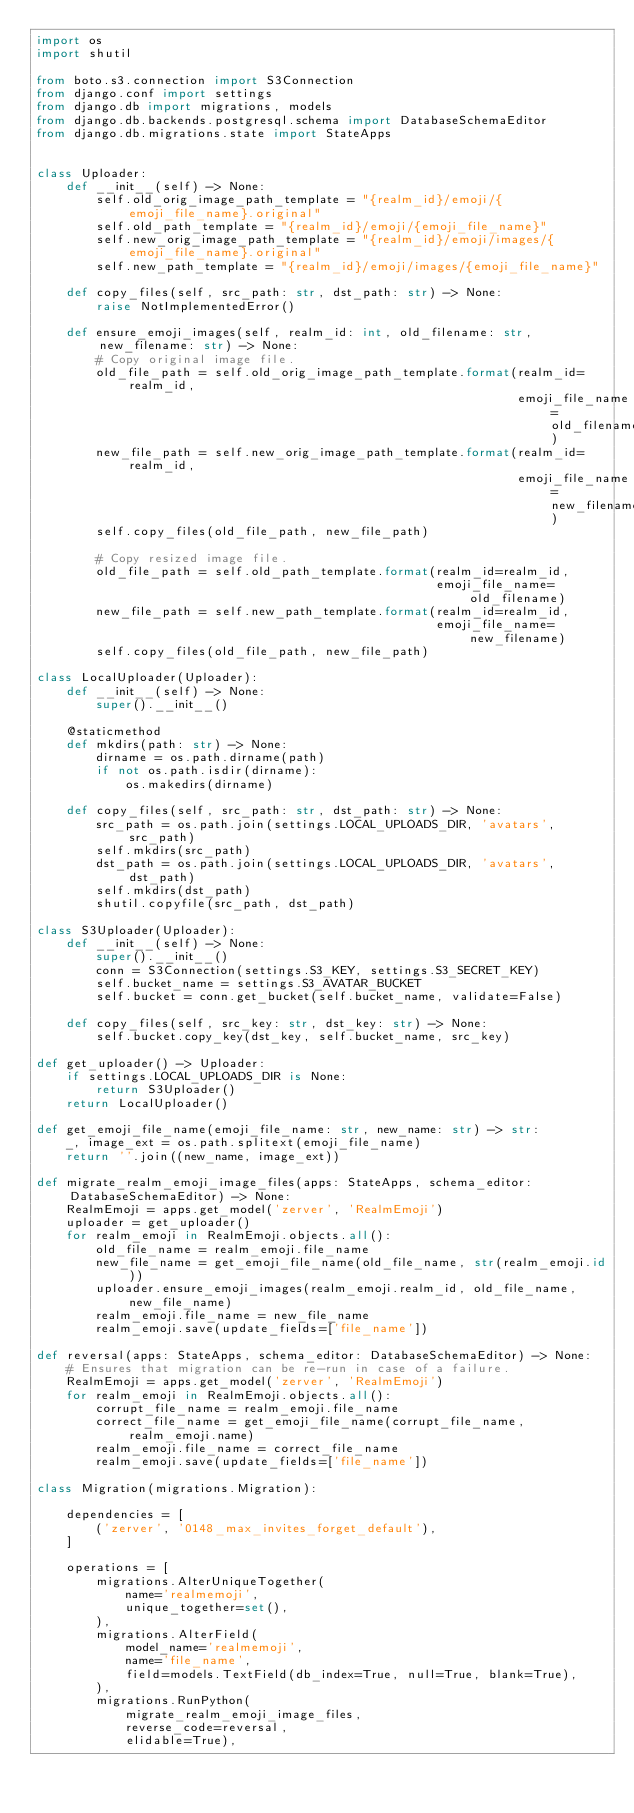Convert code to text. <code><loc_0><loc_0><loc_500><loc_500><_Python_>import os
import shutil

from boto.s3.connection import S3Connection
from django.conf import settings
from django.db import migrations, models
from django.db.backends.postgresql.schema import DatabaseSchemaEditor
from django.db.migrations.state import StateApps


class Uploader:
    def __init__(self) -> None:
        self.old_orig_image_path_template = "{realm_id}/emoji/{emoji_file_name}.original"
        self.old_path_template = "{realm_id}/emoji/{emoji_file_name}"
        self.new_orig_image_path_template = "{realm_id}/emoji/images/{emoji_file_name}.original"
        self.new_path_template = "{realm_id}/emoji/images/{emoji_file_name}"

    def copy_files(self, src_path: str, dst_path: str) -> None:
        raise NotImplementedError()

    def ensure_emoji_images(self, realm_id: int, old_filename: str, new_filename: str) -> None:
        # Copy original image file.
        old_file_path = self.old_orig_image_path_template.format(realm_id=realm_id,
                                                                 emoji_file_name=old_filename)
        new_file_path = self.new_orig_image_path_template.format(realm_id=realm_id,
                                                                 emoji_file_name=new_filename)
        self.copy_files(old_file_path, new_file_path)

        # Copy resized image file.
        old_file_path = self.old_path_template.format(realm_id=realm_id,
                                                      emoji_file_name=old_filename)
        new_file_path = self.new_path_template.format(realm_id=realm_id,
                                                      emoji_file_name=new_filename)
        self.copy_files(old_file_path, new_file_path)

class LocalUploader(Uploader):
    def __init__(self) -> None:
        super().__init__()

    @staticmethod
    def mkdirs(path: str) -> None:
        dirname = os.path.dirname(path)
        if not os.path.isdir(dirname):
            os.makedirs(dirname)

    def copy_files(self, src_path: str, dst_path: str) -> None:
        src_path = os.path.join(settings.LOCAL_UPLOADS_DIR, 'avatars', src_path)
        self.mkdirs(src_path)
        dst_path = os.path.join(settings.LOCAL_UPLOADS_DIR, 'avatars', dst_path)
        self.mkdirs(dst_path)
        shutil.copyfile(src_path, dst_path)

class S3Uploader(Uploader):
    def __init__(self) -> None:
        super().__init__()
        conn = S3Connection(settings.S3_KEY, settings.S3_SECRET_KEY)
        self.bucket_name = settings.S3_AVATAR_BUCKET
        self.bucket = conn.get_bucket(self.bucket_name, validate=False)

    def copy_files(self, src_key: str, dst_key: str) -> None:
        self.bucket.copy_key(dst_key, self.bucket_name, src_key)

def get_uploader() -> Uploader:
    if settings.LOCAL_UPLOADS_DIR is None:
        return S3Uploader()
    return LocalUploader()

def get_emoji_file_name(emoji_file_name: str, new_name: str) -> str:
    _, image_ext = os.path.splitext(emoji_file_name)
    return ''.join((new_name, image_ext))

def migrate_realm_emoji_image_files(apps: StateApps, schema_editor: DatabaseSchemaEditor) -> None:
    RealmEmoji = apps.get_model('zerver', 'RealmEmoji')
    uploader = get_uploader()
    for realm_emoji in RealmEmoji.objects.all():
        old_file_name = realm_emoji.file_name
        new_file_name = get_emoji_file_name(old_file_name, str(realm_emoji.id))
        uploader.ensure_emoji_images(realm_emoji.realm_id, old_file_name, new_file_name)
        realm_emoji.file_name = new_file_name
        realm_emoji.save(update_fields=['file_name'])

def reversal(apps: StateApps, schema_editor: DatabaseSchemaEditor) -> None:
    # Ensures that migration can be re-run in case of a failure.
    RealmEmoji = apps.get_model('zerver', 'RealmEmoji')
    for realm_emoji in RealmEmoji.objects.all():
        corrupt_file_name = realm_emoji.file_name
        correct_file_name = get_emoji_file_name(corrupt_file_name, realm_emoji.name)
        realm_emoji.file_name = correct_file_name
        realm_emoji.save(update_fields=['file_name'])

class Migration(migrations.Migration):

    dependencies = [
        ('zerver', '0148_max_invites_forget_default'),
    ]

    operations = [
        migrations.AlterUniqueTogether(
            name='realmemoji',
            unique_together=set(),
        ),
        migrations.AlterField(
            model_name='realmemoji',
            name='file_name',
            field=models.TextField(db_index=True, null=True, blank=True),
        ),
        migrations.RunPython(
            migrate_realm_emoji_image_files,
            reverse_code=reversal,
            elidable=True),</code> 